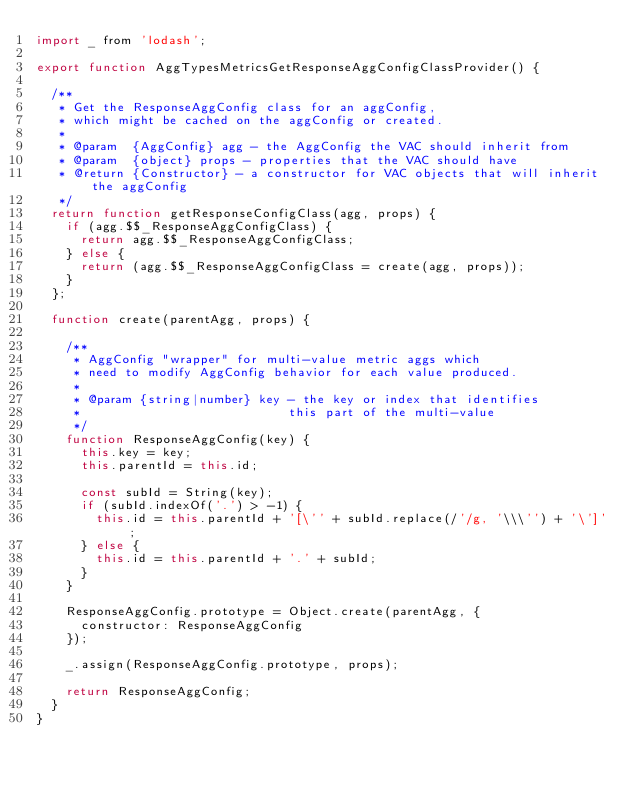<code> <loc_0><loc_0><loc_500><loc_500><_JavaScript_>import _ from 'lodash';

export function AggTypesMetricsGetResponseAggConfigClassProvider() {

  /**
   * Get the ResponseAggConfig class for an aggConfig,
   * which might be cached on the aggConfig or created.
   *
   * @param  {AggConfig} agg - the AggConfig the VAC should inherit from
   * @param  {object} props - properties that the VAC should have
   * @return {Constructor} - a constructor for VAC objects that will inherit the aggConfig
   */
  return function getResponseConfigClass(agg, props) {
    if (agg.$$_ResponseAggConfigClass) {
      return agg.$$_ResponseAggConfigClass;
    } else {
      return (agg.$$_ResponseAggConfigClass = create(agg, props));
    }
  };

  function create(parentAgg, props) {

    /**
     * AggConfig "wrapper" for multi-value metric aggs which
     * need to modify AggConfig behavior for each value produced.
     *
     * @param {string|number} key - the key or index that identifies
     *                            this part of the multi-value
     */
    function ResponseAggConfig(key) {
      this.key = key;
      this.parentId = this.id;

      const subId = String(key);
      if (subId.indexOf('.') > -1) {
        this.id = this.parentId + '[\'' + subId.replace(/'/g, '\\\'') + '\']';
      } else {
        this.id = this.parentId + '.' + subId;
      }
    }

    ResponseAggConfig.prototype = Object.create(parentAgg, {
      constructor: ResponseAggConfig
    });

    _.assign(ResponseAggConfig.prototype, props);

    return ResponseAggConfig;
  }
}
</code> 